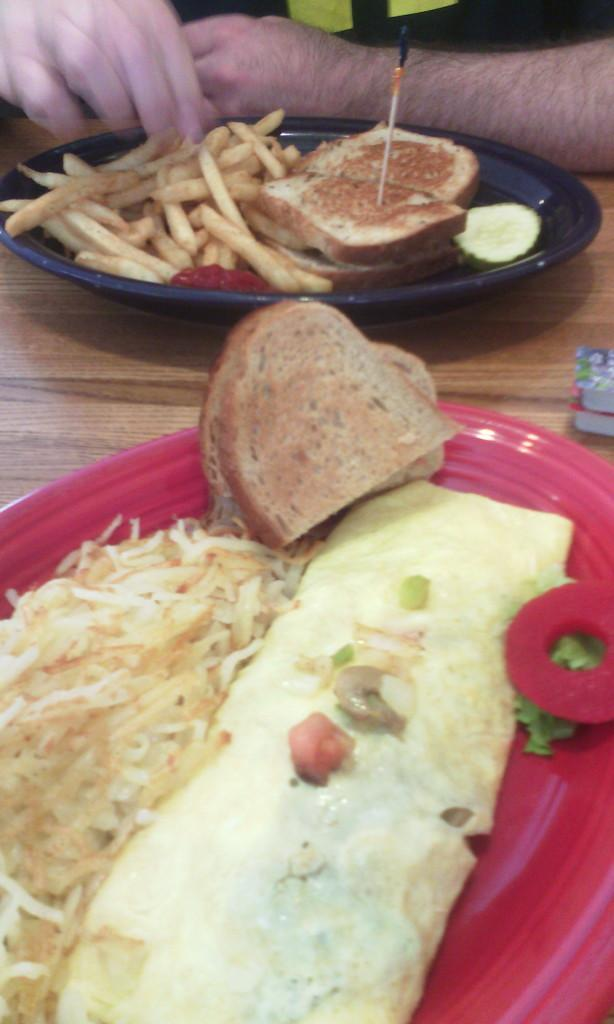What objects are present on the plates in the image? There is food on the plates in the image. Can you describe the person in the background of the image? Unfortunately, the provided facts do not give any information about the person in the background. What is the primary purpose of the plates in the image? The primary purpose of the plates in the image is to hold food. What type of collar is the cat wearing in the image? There is no cat or collar present in the image. 